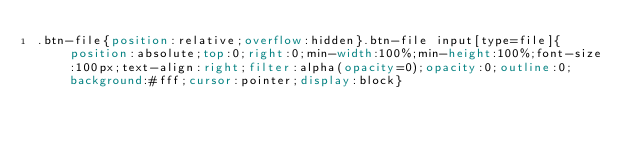<code> <loc_0><loc_0><loc_500><loc_500><_CSS_>.btn-file{position:relative;overflow:hidden}.btn-file input[type=file]{position:absolute;top:0;right:0;min-width:100%;min-height:100%;font-size:100px;text-align:right;filter:alpha(opacity=0);opacity:0;outline:0;background:#fff;cursor:pointer;display:block}</code> 